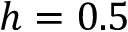Convert formula to latex. <formula><loc_0><loc_0><loc_500><loc_500>h = 0 . 5</formula> 